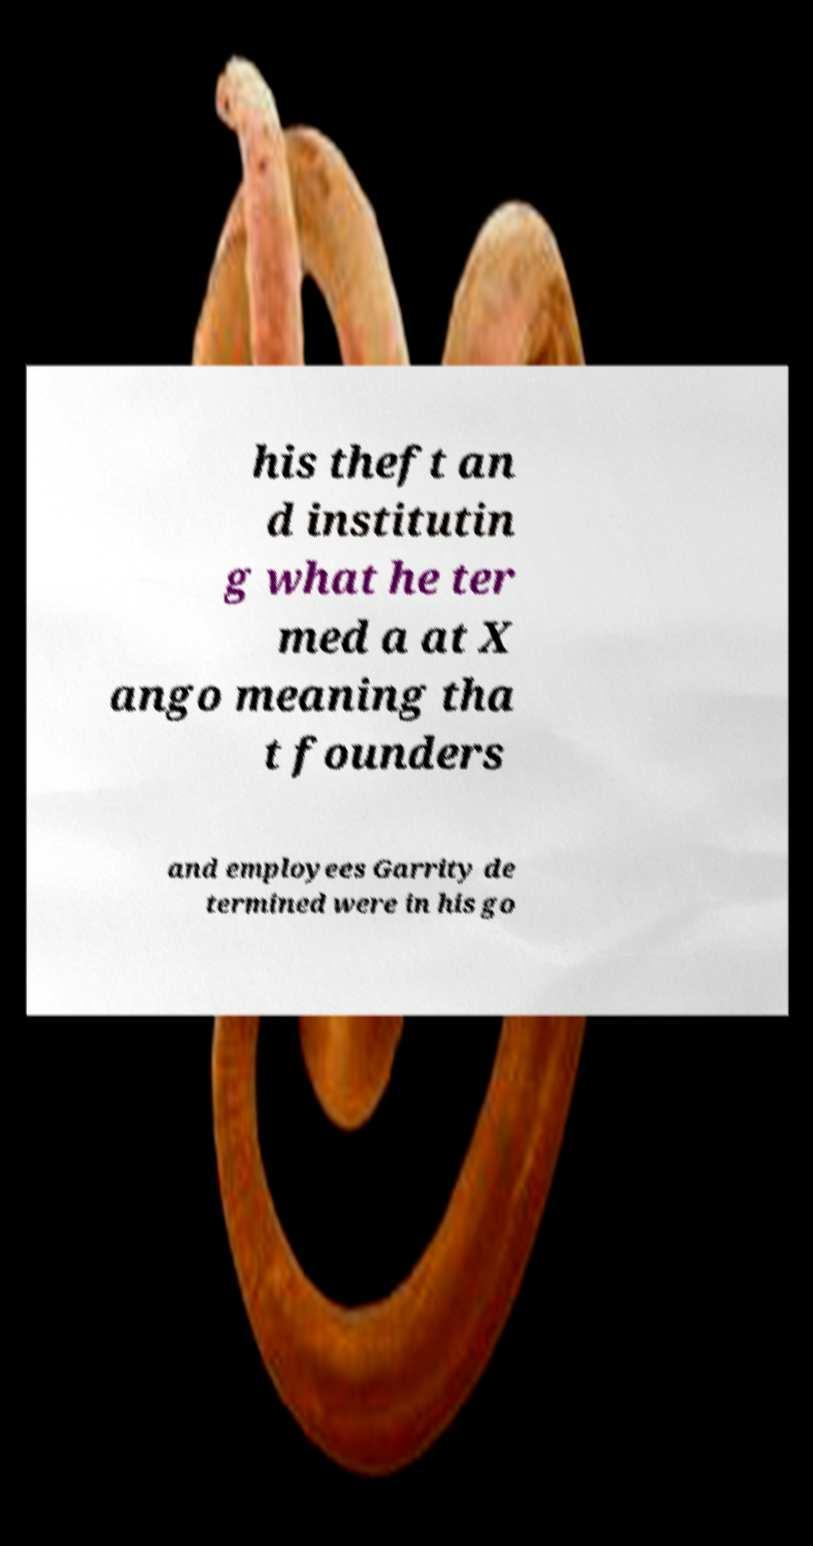Please read and relay the text visible in this image. What does it say? his theft an d institutin g what he ter med a at X ango meaning tha t founders and employees Garrity de termined were in his go 